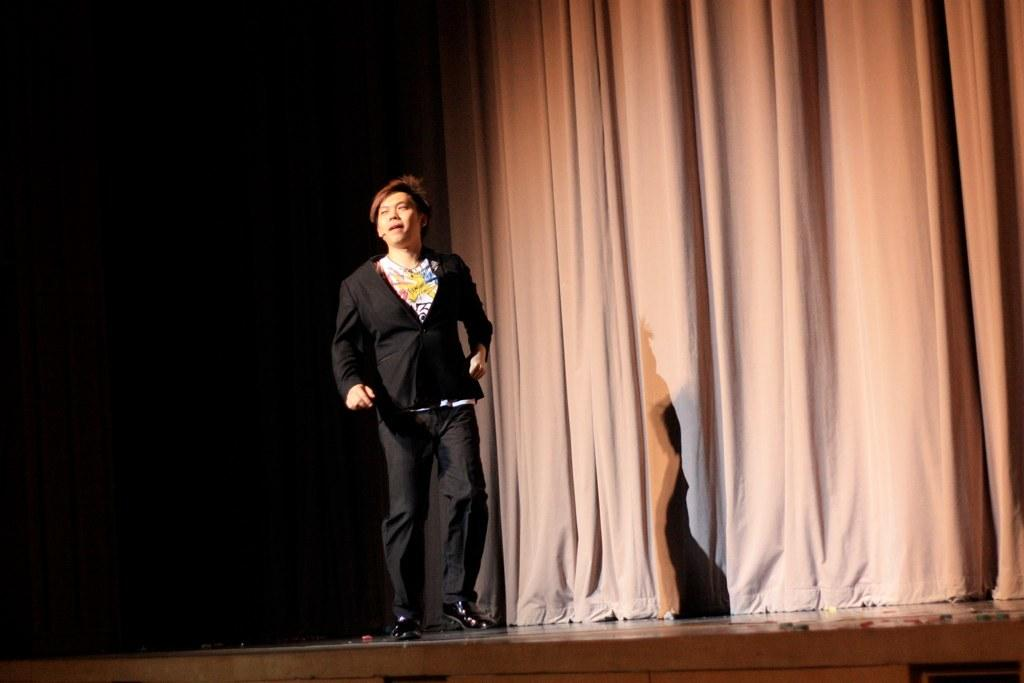What is the main subject of the image? There is a person in the image. What is the person wearing? The person is wearing a black dress. Where is the person located in the image? The person is standing on a stage. What can be seen in the background of the image? There is a cream curtain in the background, and the background is black. What type of loaf is being used as a prop on the stage? There is no loaf present in the image. What type of wool is being used to make the person's dress? The person's dress is not made of wool; it is a black dress. 